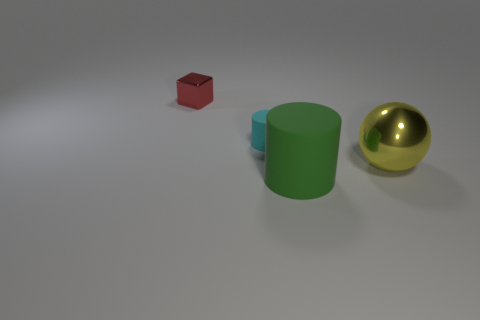Add 3 large shiny spheres. How many objects exist? 7 Subtract all cubes. How many objects are left? 3 Add 1 big yellow objects. How many big yellow objects exist? 2 Subtract 0 cyan spheres. How many objects are left? 4 Subtract all small yellow rubber blocks. Subtract all large green rubber things. How many objects are left? 3 Add 1 big green cylinders. How many big green cylinders are left? 2 